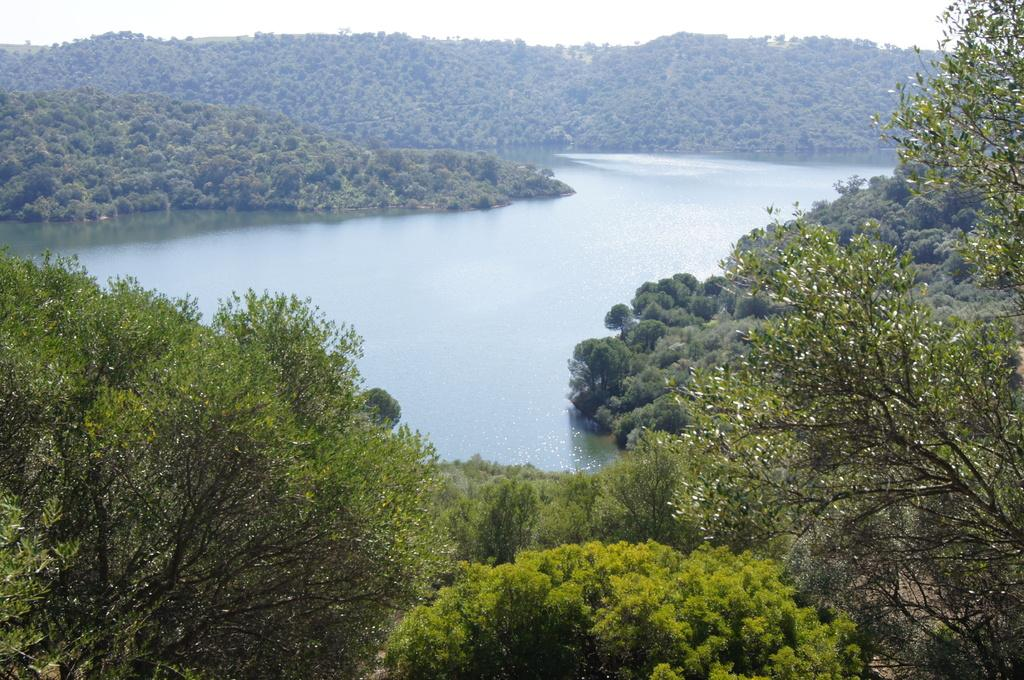What type of natural feature is present in the image? There is a river in the picture. What other geographical feature can be seen in the image? There are mountains in the picture. How are the mountains described in the image? The mountains are covered with trees. What is the condition of the sky in the image? The sky is clear in the image. How many turkeys can be seen roaming around in the image? There are no turkeys present in the image; it features a river, mountains, and trees. What type of tax is being discussed in the image? There is no discussion of taxes in the image; it focuses on natural landscapes. 